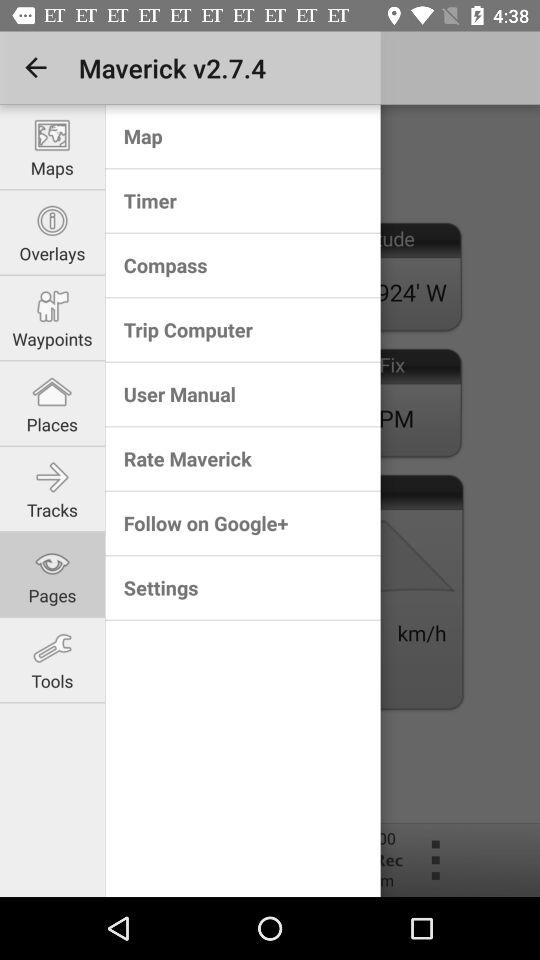What is the version of Maverick? The version is 2.7.4. 